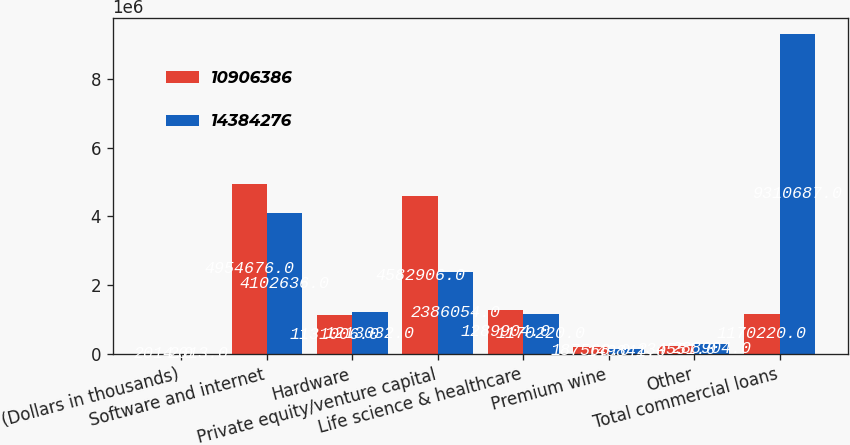Convert chart. <chart><loc_0><loc_0><loc_500><loc_500><stacked_bar_chart><ecel><fcel>(Dollars in thousands)<fcel>Software and internet<fcel>Hardware<fcel>Private equity/venture capital<fcel>Life science & healthcare<fcel>Premium wine<fcel>Other<fcel>Total commercial loans<nl><fcel>1.09064e+07<fcel>2014<fcel>4.95468e+06<fcel>1.13101e+06<fcel>4.58291e+06<fcel>1.2899e+06<fcel>187568<fcel>234551<fcel>1.17022e+06<nl><fcel>1.43843e+07<fcel>2013<fcel>4.10264e+06<fcel>1.21303e+06<fcel>2.38605e+06<fcel>1.17022e+06<fcel>149841<fcel>288904<fcel>9.31069e+06<nl></chart> 